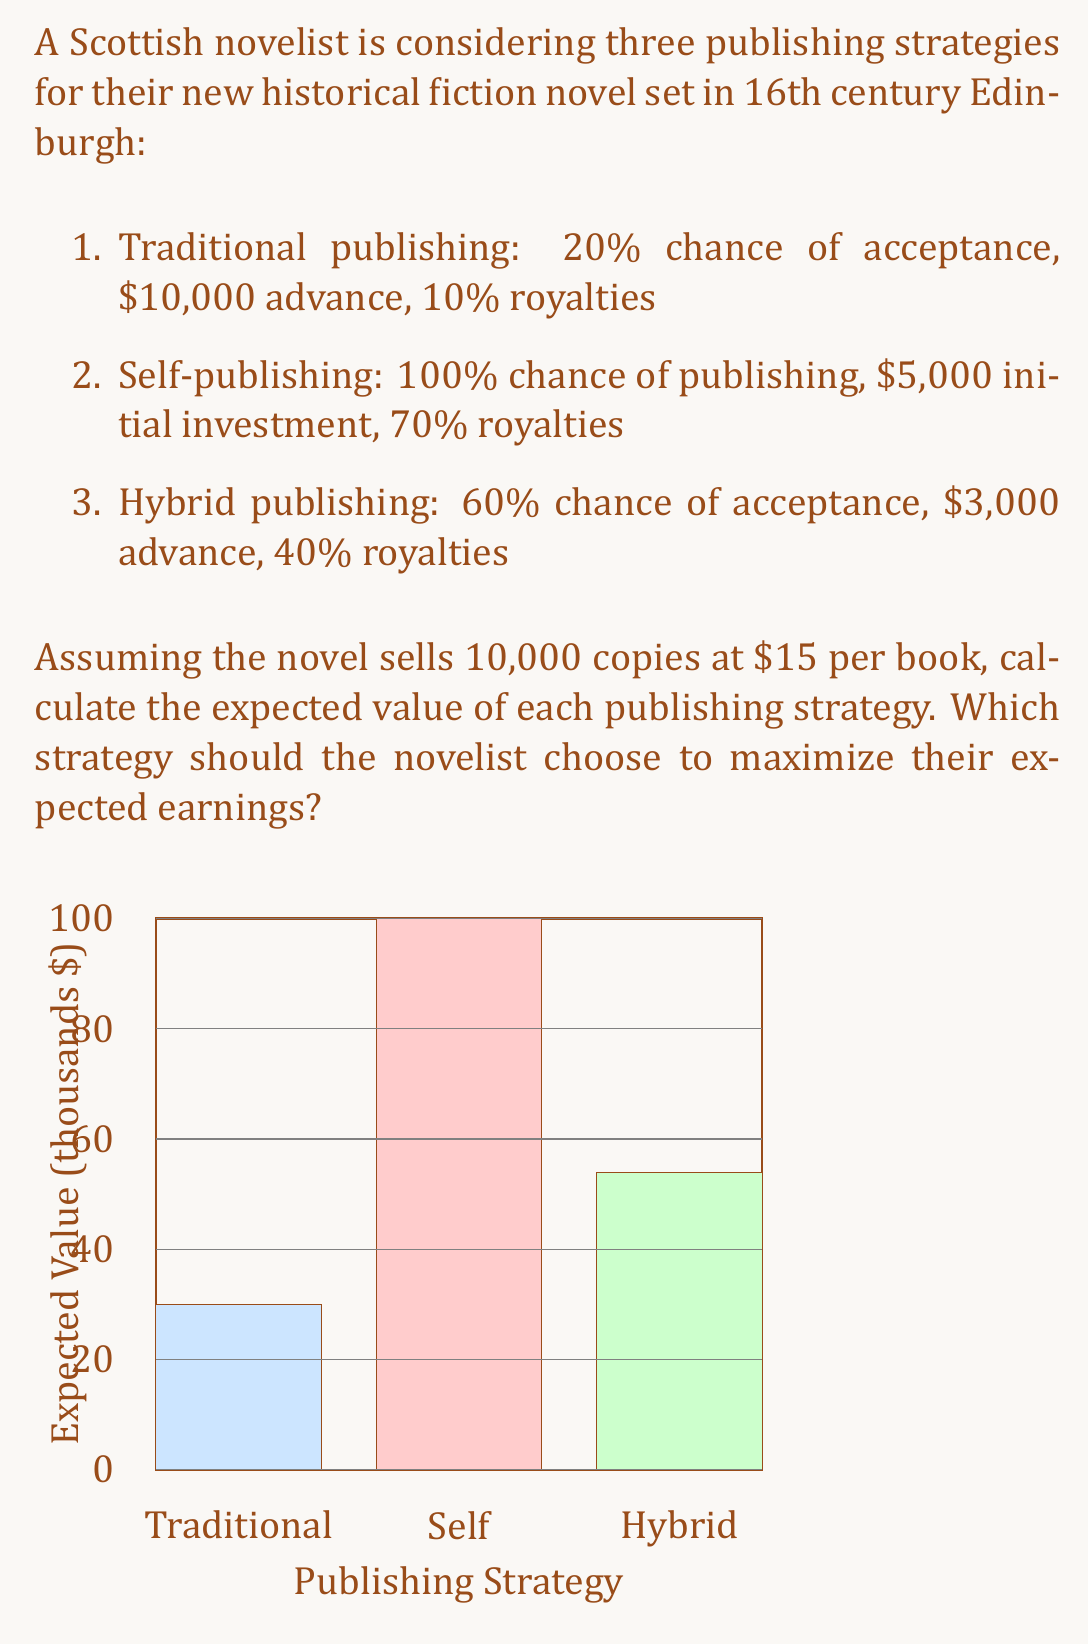Could you help me with this problem? Let's calculate the expected value for each publishing strategy:

1. Traditional publishing:
   - Probability of acceptance: 20% = 0.2
   - Expected advance: $10,000
   - Expected royalties: 10% of (10,000 copies * $15/copy) = $15,000
   
   Expected Value = $0.2 * (10,000 + 15,000) = $5,000$

2. Self-publishing:
   - Probability of publishing: 100% = 1
   - Initial investment: -$5,000
   - Expected royalties: 70% of (10,000 copies * $15/copy) = $105,000
   
   Expected Value = $1 * (-5,000 + 105,000) = $100,000$

3. Hybrid publishing:
   - Probability of acceptance: 60% = 0.6
   - Expected advance: $3,000
   - Expected royalties: 40% of (10,000 copies * $15/copy) = $60,000
   
   Expected Value = $0.6 * (3,000 + 60,000) = $37,800$

To find the strategy that maximizes expected earnings, we compare the expected values:

$$\text{Self-publishing} > \text{Hybrid publishing} > \text{Traditional publishing}$$
$$100,000 > 37,800 > 5,000$$

Therefore, the novelist should choose the self-publishing strategy to maximize their expected earnings.
Answer: Self-publishing strategy, with an expected value of $100,000. 